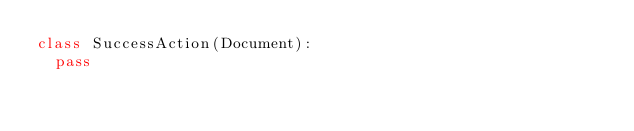<code> <loc_0><loc_0><loc_500><loc_500><_Python_>class SuccessAction(Document):
	pass
</code> 